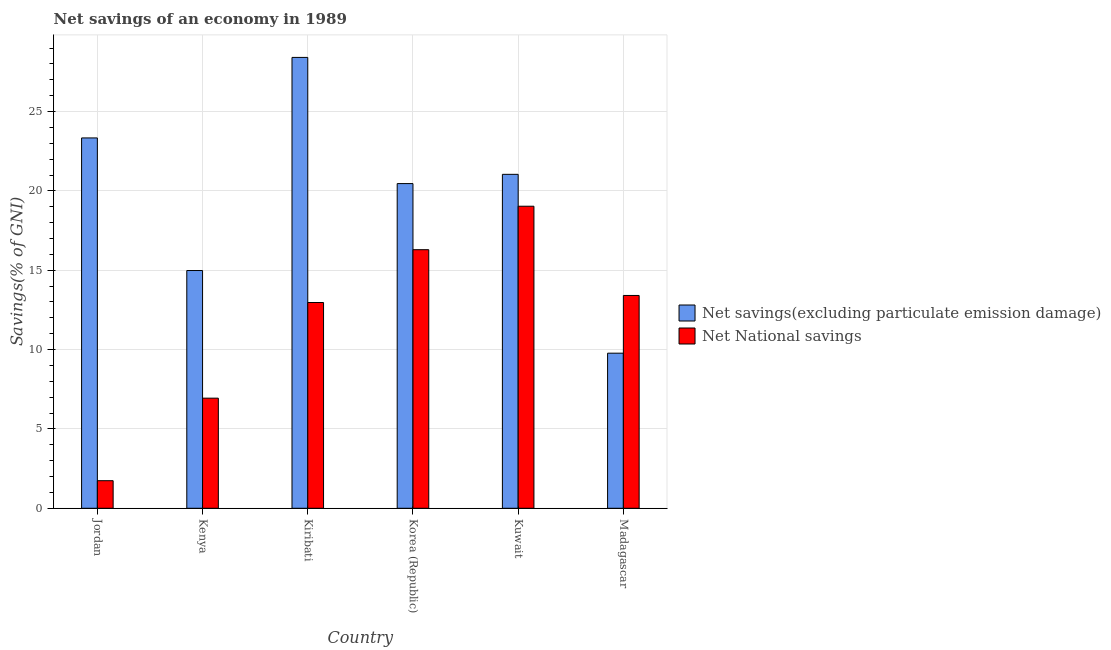How many different coloured bars are there?
Give a very brief answer. 2. How many groups of bars are there?
Your answer should be compact. 6. Are the number of bars on each tick of the X-axis equal?
Your answer should be very brief. Yes. How many bars are there on the 5th tick from the left?
Give a very brief answer. 2. How many bars are there on the 6th tick from the right?
Provide a short and direct response. 2. What is the label of the 2nd group of bars from the left?
Offer a terse response. Kenya. What is the net national savings in Kuwait?
Make the answer very short. 19.03. Across all countries, what is the maximum net savings(excluding particulate emission damage)?
Provide a succinct answer. 28.41. Across all countries, what is the minimum net savings(excluding particulate emission damage)?
Make the answer very short. 9.77. In which country was the net national savings maximum?
Offer a terse response. Kuwait. In which country was the net savings(excluding particulate emission damage) minimum?
Make the answer very short. Madagascar. What is the total net savings(excluding particulate emission damage) in the graph?
Your answer should be very brief. 118.02. What is the difference between the net savings(excluding particulate emission damage) in Korea (Republic) and that in Kuwait?
Give a very brief answer. -0.58. What is the difference between the net savings(excluding particulate emission damage) in Madagascar and the net national savings in Korea (Republic)?
Offer a very short reply. -6.52. What is the average net national savings per country?
Offer a terse response. 11.73. What is the difference between the net savings(excluding particulate emission damage) and net national savings in Kenya?
Ensure brevity in your answer.  8.04. In how many countries, is the net national savings greater than 10 %?
Your response must be concise. 4. What is the ratio of the net savings(excluding particulate emission damage) in Jordan to that in Madagascar?
Offer a very short reply. 2.39. Is the net savings(excluding particulate emission damage) in Kenya less than that in Korea (Republic)?
Offer a terse response. Yes. Is the difference between the net savings(excluding particulate emission damage) in Jordan and Kuwait greater than the difference between the net national savings in Jordan and Kuwait?
Your answer should be very brief. Yes. What is the difference between the highest and the second highest net savings(excluding particulate emission damage)?
Ensure brevity in your answer.  5.07. What is the difference between the highest and the lowest net national savings?
Your response must be concise. 17.3. In how many countries, is the net national savings greater than the average net national savings taken over all countries?
Offer a terse response. 4. What does the 1st bar from the left in Korea (Republic) represents?
Make the answer very short. Net savings(excluding particulate emission damage). What does the 2nd bar from the right in Madagascar represents?
Offer a very short reply. Net savings(excluding particulate emission damage). Are all the bars in the graph horizontal?
Make the answer very short. No. Are the values on the major ticks of Y-axis written in scientific E-notation?
Your answer should be very brief. No. Does the graph contain grids?
Provide a short and direct response. Yes. How many legend labels are there?
Provide a short and direct response. 2. How are the legend labels stacked?
Provide a succinct answer. Vertical. What is the title of the graph?
Your answer should be compact. Net savings of an economy in 1989. Does "Health Care" appear as one of the legend labels in the graph?
Offer a very short reply. No. What is the label or title of the Y-axis?
Your response must be concise. Savings(% of GNI). What is the Savings(% of GNI) in Net savings(excluding particulate emission damage) in Jordan?
Offer a very short reply. 23.34. What is the Savings(% of GNI) of Net National savings in Jordan?
Your answer should be very brief. 1.74. What is the Savings(% of GNI) of Net savings(excluding particulate emission damage) in Kenya?
Make the answer very short. 14.98. What is the Savings(% of GNI) in Net National savings in Kenya?
Your answer should be compact. 6.94. What is the Savings(% of GNI) of Net savings(excluding particulate emission damage) in Kiribati?
Ensure brevity in your answer.  28.41. What is the Savings(% of GNI) in Net National savings in Kiribati?
Your answer should be compact. 12.97. What is the Savings(% of GNI) of Net savings(excluding particulate emission damage) in Korea (Republic)?
Offer a terse response. 20.46. What is the Savings(% of GNI) of Net National savings in Korea (Republic)?
Make the answer very short. 16.3. What is the Savings(% of GNI) of Net savings(excluding particulate emission damage) in Kuwait?
Provide a succinct answer. 21.04. What is the Savings(% of GNI) in Net National savings in Kuwait?
Provide a succinct answer. 19.03. What is the Savings(% of GNI) in Net savings(excluding particulate emission damage) in Madagascar?
Offer a terse response. 9.77. What is the Savings(% of GNI) in Net National savings in Madagascar?
Provide a succinct answer. 13.41. Across all countries, what is the maximum Savings(% of GNI) of Net savings(excluding particulate emission damage)?
Give a very brief answer. 28.41. Across all countries, what is the maximum Savings(% of GNI) in Net National savings?
Make the answer very short. 19.03. Across all countries, what is the minimum Savings(% of GNI) of Net savings(excluding particulate emission damage)?
Your answer should be compact. 9.77. Across all countries, what is the minimum Savings(% of GNI) in Net National savings?
Your answer should be compact. 1.74. What is the total Savings(% of GNI) of Net savings(excluding particulate emission damage) in the graph?
Provide a succinct answer. 118.02. What is the total Savings(% of GNI) of Net National savings in the graph?
Offer a terse response. 70.39. What is the difference between the Savings(% of GNI) of Net savings(excluding particulate emission damage) in Jordan and that in Kenya?
Your response must be concise. 8.36. What is the difference between the Savings(% of GNI) in Net National savings in Jordan and that in Kenya?
Make the answer very short. -5.2. What is the difference between the Savings(% of GNI) in Net savings(excluding particulate emission damage) in Jordan and that in Kiribati?
Offer a terse response. -5.07. What is the difference between the Savings(% of GNI) of Net National savings in Jordan and that in Kiribati?
Your response must be concise. -11.23. What is the difference between the Savings(% of GNI) of Net savings(excluding particulate emission damage) in Jordan and that in Korea (Republic)?
Your answer should be compact. 2.88. What is the difference between the Savings(% of GNI) of Net National savings in Jordan and that in Korea (Republic)?
Make the answer very short. -14.56. What is the difference between the Savings(% of GNI) of Net savings(excluding particulate emission damage) in Jordan and that in Kuwait?
Give a very brief answer. 2.29. What is the difference between the Savings(% of GNI) in Net National savings in Jordan and that in Kuwait?
Offer a very short reply. -17.3. What is the difference between the Savings(% of GNI) in Net savings(excluding particulate emission damage) in Jordan and that in Madagascar?
Your response must be concise. 13.57. What is the difference between the Savings(% of GNI) of Net National savings in Jordan and that in Madagascar?
Your response must be concise. -11.67. What is the difference between the Savings(% of GNI) in Net savings(excluding particulate emission damage) in Kenya and that in Kiribati?
Offer a terse response. -13.43. What is the difference between the Savings(% of GNI) in Net National savings in Kenya and that in Kiribati?
Provide a succinct answer. -6.03. What is the difference between the Savings(% of GNI) in Net savings(excluding particulate emission damage) in Kenya and that in Korea (Republic)?
Ensure brevity in your answer.  -5.48. What is the difference between the Savings(% of GNI) in Net National savings in Kenya and that in Korea (Republic)?
Provide a succinct answer. -9.36. What is the difference between the Savings(% of GNI) in Net savings(excluding particulate emission damage) in Kenya and that in Kuwait?
Keep it short and to the point. -6.06. What is the difference between the Savings(% of GNI) of Net National savings in Kenya and that in Kuwait?
Offer a terse response. -12.1. What is the difference between the Savings(% of GNI) in Net savings(excluding particulate emission damage) in Kenya and that in Madagascar?
Give a very brief answer. 5.21. What is the difference between the Savings(% of GNI) in Net National savings in Kenya and that in Madagascar?
Make the answer very short. -6.47. What is the difference between the Savings(% of GNI) in Net savings(excluding particulate emission damage) in Kiribati and that in Korea (Republic)?
Make the answer very short. 7.95. What is the difference between the Savings(% of GNI) of Net National savings in Kiribati and that in Korea (Republic)?
Your answer should be very brief. -3.33. What is the difference between the Savings(% of GNI) of Net savings(excluding particulate emission damage) in Kiribati and that in Kuwait?
Make the answer very short. 7.37. What is the difference between the Savings(% of GNI) of Net National savings in Kiribati and that in Kuwait?
Give a very brief answer. -6.07. What is the difference between the Savings(% of GNI) of Net savings(excluding particulate emission damage) in Kiribati and that in Madagascar?
Provide a short and direct response. 18.64. What is the difference between the Savings(% of GNI) of Net National savings in Kiribati and that in Madagascar?
Offer a terse response. -0.44. What is the difference between the Savings(% of GNI) of Net savings(excluding particulate emission damage) in Korea (Republic) and that in Kuwait?
Make the answer very short. -0.58. What is the difference between the Savings(% of GNI) in Net National savings in Korea (Republic) and that in Kuwait?
Offer a very short reply. -2.74. What is the difference between the Savings(% of GNI) of Net savings(excluding particulate emission damage) in Korea (Republic) and that in Madagascar?
Offer a very short reply. 10.69. What is the difference between the Savings(% of GNI) in Net National savings in Korea (Republic) and that in Madagascar?
Your response must be concise. 2.88. What is the difference between the Savings(% of GNI) in Net savings(excluding particulate emission damage) in Kuwait and that in Madagascar?
Offer a terse response. 11.27. What is the difference between the Savings(% of GNI) in Net National savings in Kuwait and that in Madagascar?
Your answer should be compact. 5.62. What is the difference between the Savings(% of GNI) in Net savings(excluding particulate emission damage) in Jordan and the Savings(% of GNI) in Net National savings in Kenya?
Provide a succinct answer. 16.4. What is the difference between the Savings(% of GNI) in Net savings(excluding particulate emission damage) in Jordan and the Savings(% of GNI) in Net National savings in Kiribati?
Give a very brief answer. 10.37. What is the difference between the Savings(% of GNI) in Net savings(excluding particulate emission damage) in Jordan and the Savings(% of GNI) in Net National savings in Korea (Republic)?
Offer a very short reply. 7.04. What is the difference between the Savings(% of GNI) of Net savings(excluding particulate emission damage) in Jordan and the Savings(% of GNI) of Net National savings in Kuwait?
Offer a very short reply. 4.3. What is the difference between the Savings(% of GNI) in Net savings(excluding particulate emission damage) in Jordan and the Savings(% of GNI) in Net National savings in Madagascar?
Your answer should be compact. 9.93. What is the difference between the Savings(% of GNI) in Net savings(excluding particulate emission damage) in Kenya and the Savings(% of GNI) in Net National savings in Kiribati?
Provide a short and direct response. 2.02. What is the difference between the Savings(% of GNI) in Net savings(excluding particulate emission damage) in Kenya and the Savings(% of GNI) in Net National savings in Korea (Republic)?
Offer a very short reply. -1.31. What is the difference between the Savings(% of GNI) of Net savings(excluding particulate emission damage) in Kenya and the Savings(% of GNI) of Net National savings in Kuwait?
Ensure brevity in your answer.  -4.05. What is the difference between the Savings(% of GNI) in Net savings(excluding particulate emission damage) in Kenya and the Savings(% of GNI) in Net National savings in Madagascar?
Your response must be concise. 1.57. What is the difference between the Savings(% of GNI) in Net savings(excluding particulate emission damage) in Kiribati and the Savings(% of GNI) in Net National savings in Korea (Republic)?
Keep it short and to the point. 12.12. What is the difference between the Savings(% of GNI) of Net savings(excluding particulate emission damage) in Kiribati and the Savings(% of GNI) of Net National savings in Kuwait?
Provide a short and direct response. 9.38. What is the difference between the Savings(% of GNI) of Net savings(excluding particulate emission damage) in Kiribati and the Savings(% of GNI) of Net National savings in Madagascar?
Provide a succinct answer. 15. What is the difference between the Savings(% of GNI) in Net savings(excluding particulate emission damage) in Korea (Republic) and the Savings(% of GNI) in Net National savings in Kuwait?
Offer a very short reply. 1.43. What is the difference between the Savings(% of GNI) in Net savings(excluding particulate emission damage) in Korea (Republic) and the Savings(% of GNI) in Net National savings in Madagascar?
Offer a terse response. 7.05. What is the difference between the Savings(% of GNI) of Net savings(excluding particulate emission damage) in Kuwait and the Savings(% of GNI) of Net National savings in Madagascar?
Give a very brief answer. 7.63. What is the average Savings(% of GNI) of Net savings(excluding particulate emission damage) per country?
Provide a succinct answer. 19.67. What is the average Savings(% of GNI) of Net National savings per country?
Ensure brevity in your answer.  11.73. What is the difference between the Savings(% of GNI) in Net savings(excluding particulate emission damage) and Savings(% of GNI) in Net National savings in Jordan?
Offer a very short reply. 21.6. What is the difference between the Savings(% of GNI) in Net savings(excluding particulate emission damage) and Savings(% of GNI) in Net National savings in Kenya?
Provide a short and direct response. 8.04. What is the difference between the Savings(% of GNI) of Net savings(excluding particulate emission damage) and Savings(% of GNI) of Net National savings in Kiribati?
Make the answer very short. 15.45. What is the difference between the Savings(% of GNI) of Net savings(excluding particulate emission damage) and Savings(% of GNI) of Net National savings in Korea (Republic)?
Offer a terse response. 4.17. What is the difference between the Savings(% of GNI) in Net savings(excluding particulate emission damage) and Savings(% of GNI) in Net National savings in Kuwait?
Make the answer very short. 2.01. What is the difference between the Savings(% of GNI) in Net savings(excluding particulate emission damage) and Savings(% of GNI) in Net National savings in Madagascar?
Your answer should be compact. -3.64. What is the ratio of the Savings(% of GNI) in Net savings(excluding particulate emission damage) in Jordan to that in Kenya?
Your answer should be compact. 1.56. What is the ratio of the Savings(% of GNI) of Net National savings in Jordan to that in Kenya?
Your answer should be compact. 0.25. What is the ratio of the Savings(% of GNI) of Net savings(excluding particulate emission damage) in Jordan to that in Kiribati?
Your response must be concise. 0.82. What is the ratio of the Savings(% of GNI) in Net National savings in Jordan to that in Kiribati?
Your response must be concise. 0.13. What is the ratio of the Savings(% of GNI) in Net savings(excluding particulate emission damage) in Jordan to that in Korea (Republic)?
Make the answer very short. 1.14. What is the ratio of the Savings(% of GNI) of Net National savings in Jordan to that in Korea (Republic)?
Provide a short and direct response. 0.11. What is the ratio of the Savings(% of GNI) in Net savings(excluding particulate emission damage) in Jordan to that in Kuwait?
Your answer should be compact. 1.11. What is the ratio of the Savings(% of GNI) in Net National savings in Jordan to that in Kuwait?
Ensure brevity in your answer.  0.09. What is the ratio of the Savings(% of GNI) of Net savings(excluding particulate emission damage) in Jordan to that in Madagascar?
Provide a short and direct response. 2.39. What is the ratio of the Savings(% of GNI) in Net National savings in Jordan to that in Madagascar?
Keep it short and to the point. 0.13. What is the ratio of the Savings(% of GNI) of Net savings(excluding particulate emission damage) in Kenya to that in Kiribati?
Your response must be concise. 0.53. What is the ratio of the Savings(% of GNI) in Net National savings in Kenya to that in Kiribati?
Your answer should be compact. 0.54. What is the ratio of the Savings(% of GNI) in Net savings(excluding particulate emission damage) in Kenya to that in Korea (Republic)?
Your response must be concise. 0.73. What is the ratio of the Savings(% of GNI) of Net National savings in Kenya to that in Korea (Republic)?
Offer a terse response. 0.43. What is the ratio of the Savings(% of GNI) of Net savings(excluding particulate emission damage) in Kenya to that in Kuwait?
Provide a short and direct response. 0.71. What is the ratio of the Savings(% of GNI) in Net National savings in Kenya to that in Kuwait?
Your response must be concise. 0.36. What is the ratio of the Savings(% of GNI) of Net savings(excluding particulate emission damage) in Kenya to that in Madagascar?
Your answer should be very brief. 1.53. What is the ratio of the Savings(% of GNI) in Net National savings in Kenya to that in Madagascar?
Offer a very short reply. 0.52. What is the ratio of the Savings(% of GNI) of Net savings(excluding particulate emission damage) in Kiribati to that in Korea (Republic)?
Offer a terse response. 1.39. What is the ratio of the Savings(% of GNI) in Net National savings in Kiribati to that in Korea (Republic)?
Keep it short and to the point. 0.8. What is the ratio of the Savings(% of GNI) of Net savings(excluding particulate emission damage) in Kiribati to that in Kuwait?
Offer a very short reply. 1.35. What is the ratio of the Savings(% of GNI) in Net National savings in Kiribati to that in Kuwait?
Ensure brevity in your answer.  0.68. What is the ratio of the Savings(% of GNI) in Net savings(excluding particulate emission damage) in Kiribati to that in Madagascar?
Your answer should be compact. 2.91. What is the ratio of the Savings(% of GNI) of Net National savings in Kiribati to that in Madagascar?
Your answer should be compact. 0.97. What is the ratio of the Savings(% of GNI) in Net savings(excluding particulate emission damage) in Korea (Republic) to that in Kuwait?
Your answer should be very brief. 0.97. What is the ratio of the Savings(% of GNI) of Net National savings in Korea (Republic) to that in Kuwait?
Provide a succinct answer. 0.86. What is the ratio of the Savings(% of GNI) in Net savings(excluding particulate emission damage) in Korea (Republic) to that in Madagascar?
Provide a short and direct response. 2.09. What is the ratio of the Savings(% of GNI) of Net National savings in Korea (Republic) to that in Madagascar?
Ensure brevity in your answer.  1.22. What is the ratio of the Savings(% of GNI) in Net savings(excluding particulate emission damage) in Kuwait to that in Madagascar?
Your answer should be compact. 2.15. What is the ratio of the Savings(% of GNI) of Net National savings in Kuwait to that in Madagascar?
Offer a very short reply. 1.42. What is the difference between the highest and the second highest Savings(% of GNI) in Net savings(excluding particulate emission damage)?
Ensure brevity in your answer.  5.07. What is the difference between the highest and the second highest Savings(% of GNI) of Net National savings?
Ensure brevity in your answer.  2.74. What is the difference between the highest and the lowest Savings(% of GNI) in Net savings(excluding particulate emission damage)?
Keep it short and to the point. 18.64. What is the difference between the highest and the lowest Savings(% of GNI) of Net National savings?
Your response must be concise. 17.3. 